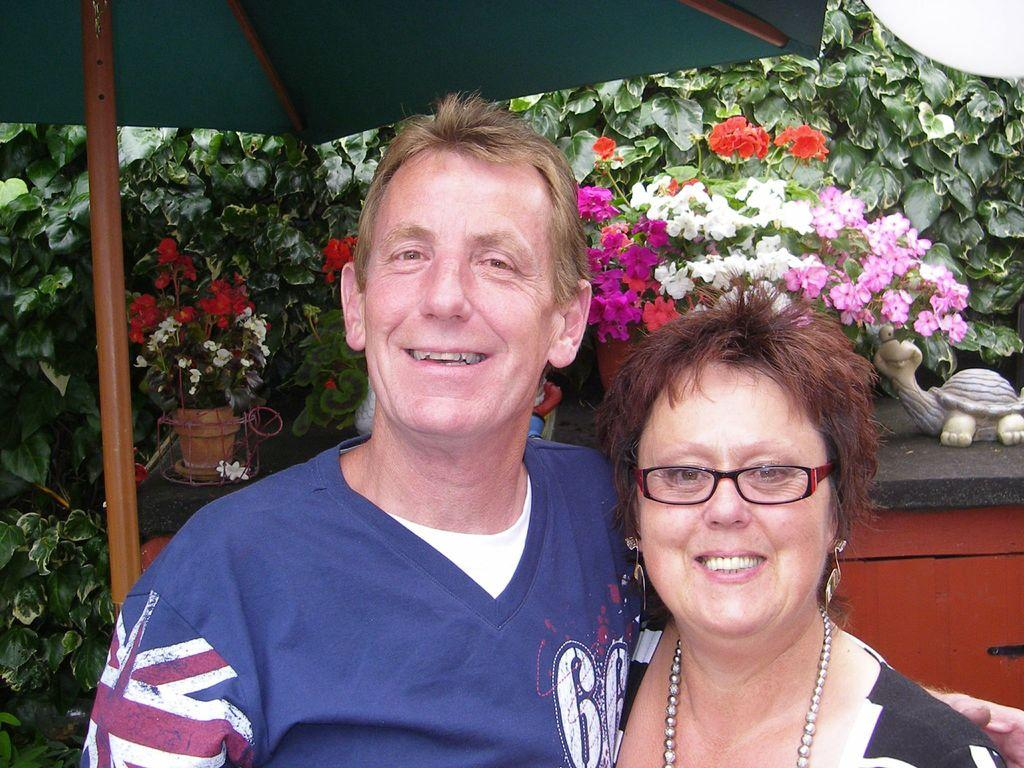How many people are in the image and what are they doing? There are two people in the image, and they are both smiling. Can you describe the woman's appearance in the image? The woman is wearing spectacles. What can be seen in the background of the image? In the background, there is a toy, pots, plants with flowers, and other objects. What type of drum can be heard playing in the background of the image? There is no drum or sound present in the image; it is a still photograph. 